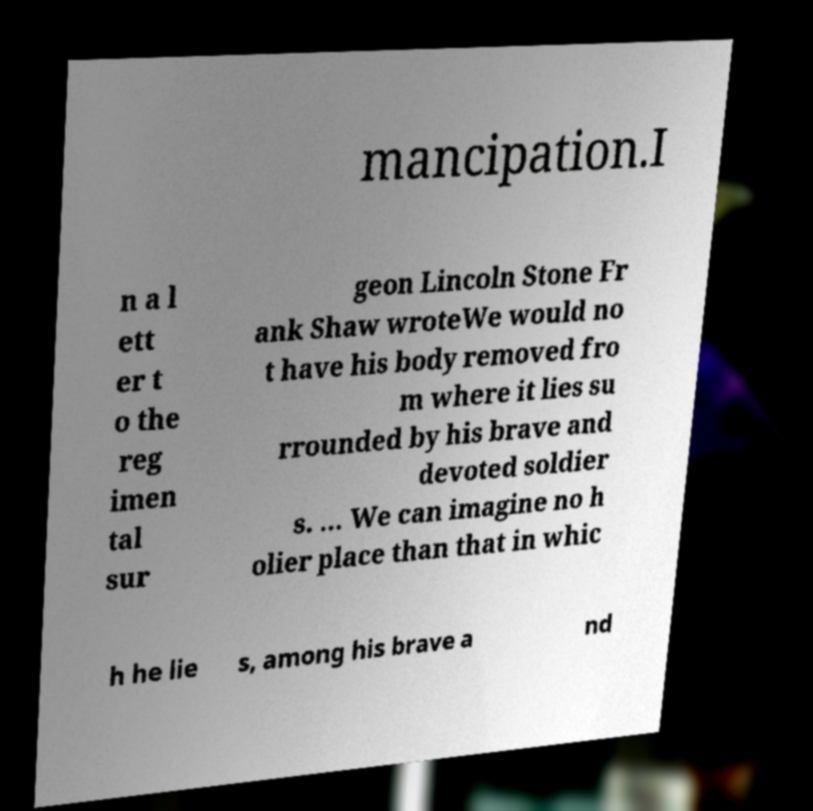What messages or text are displayed in this image? I need them in a readable, typed format. mancipation.I n a l ett er t o the reg imen tal sur geon Lincoln Stone Fr ank Shaw wroteWe would no t have his body removed fro m where it lies su rrounded by his brave and devoted soldier s. ... We can imagine no h olier place than that in whic h he lie s, among his brave a nd 